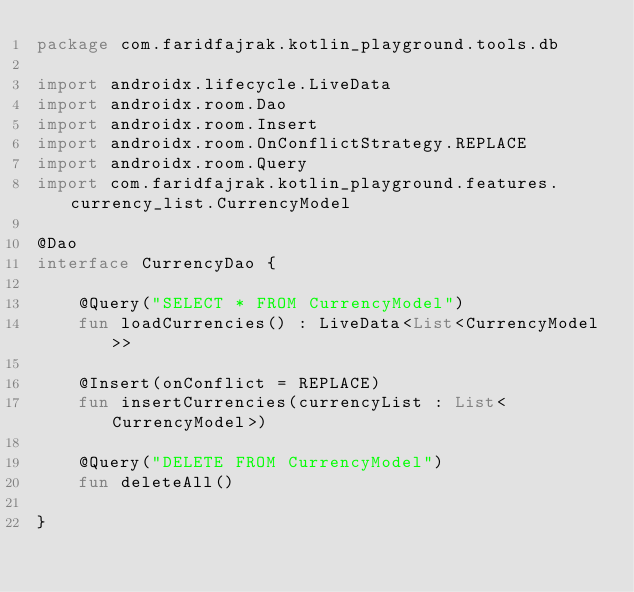Convert code to text. <code><loc_0><loc_0><loc_500><loc_500><_Kotlin_>package com.faridfajrak.kotlin_playground.tools.db

import androidx.lifecycle.LiveData
import androidx.room.Dao
import androidx.room.Insert
import androidx.room.OnConflictStrategy.REPLACE
import androidx.room.Query
import com.faridfajrak.kotlin_playground.features.currency_list.CurrencyModel

@Dao
interface CurrencyDao {

    @Query("SELECT * FROM CurrencyModel")
    fun loadCurrencies() : LiveData<List<CurrencyModel>>

    @Insert(onConflict = REPLACE)
    fun insertCurrencies(currencyList : List<CurrencyModel>)

    @Query("DELETE FROM CurrencyModel")
    fun deleteAll()

}</code> 